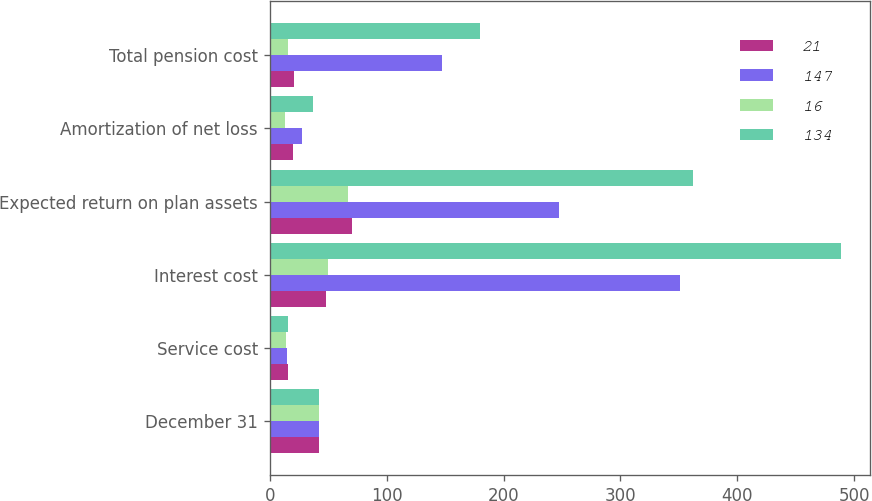Convert chart. <chart><loc_0><loc_0><loc_500><loc_500><stacked_bar_chart><ecel><fcel>December 31<fcel>Service cost<fcel>Interest cost<fcel>Expected return on plan assets<fcel>Amortization of net loss<fcel>Total pension cost<nl><fcel>21<fcel>42.5<fcel>16<fcel>48<fcel>70<fcel>20<fcel>21<nl><fcel>147<fcel>42.5<fcel>15<fcel>351<fcel>247<fcel>28<fcel>147<nl><fcel>16<fcel>42.5<fcel>14<fcel>50<fcel>67<fcel>13<fcel>16<nl><fcel>134<fcel>42.5<fcel>16<fcel>489<fcel>362<fcel>37<fcel>180<nl></chart> 